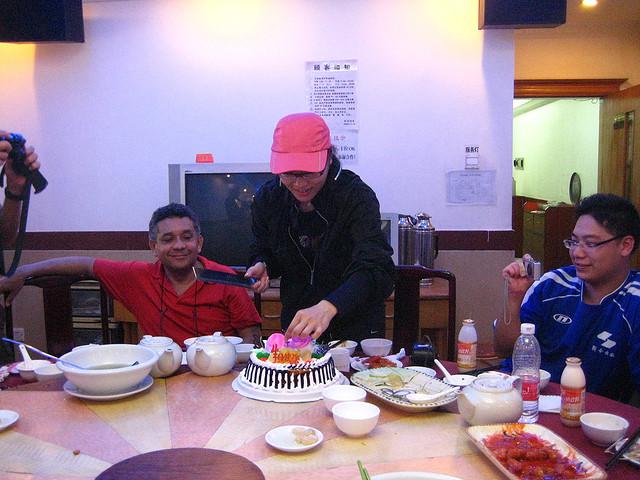What is the woman holding?
Keep it brief. Knife. How many cakes are on the table?
Keep it brief. 1. What is the man holding?
Be succinct. Knife. Is there an ashtray on the table?
Quick response, please. No. What special event is this?
Be succinct. Birthday. What color is her hat?
Write a very short answer. Pink. 